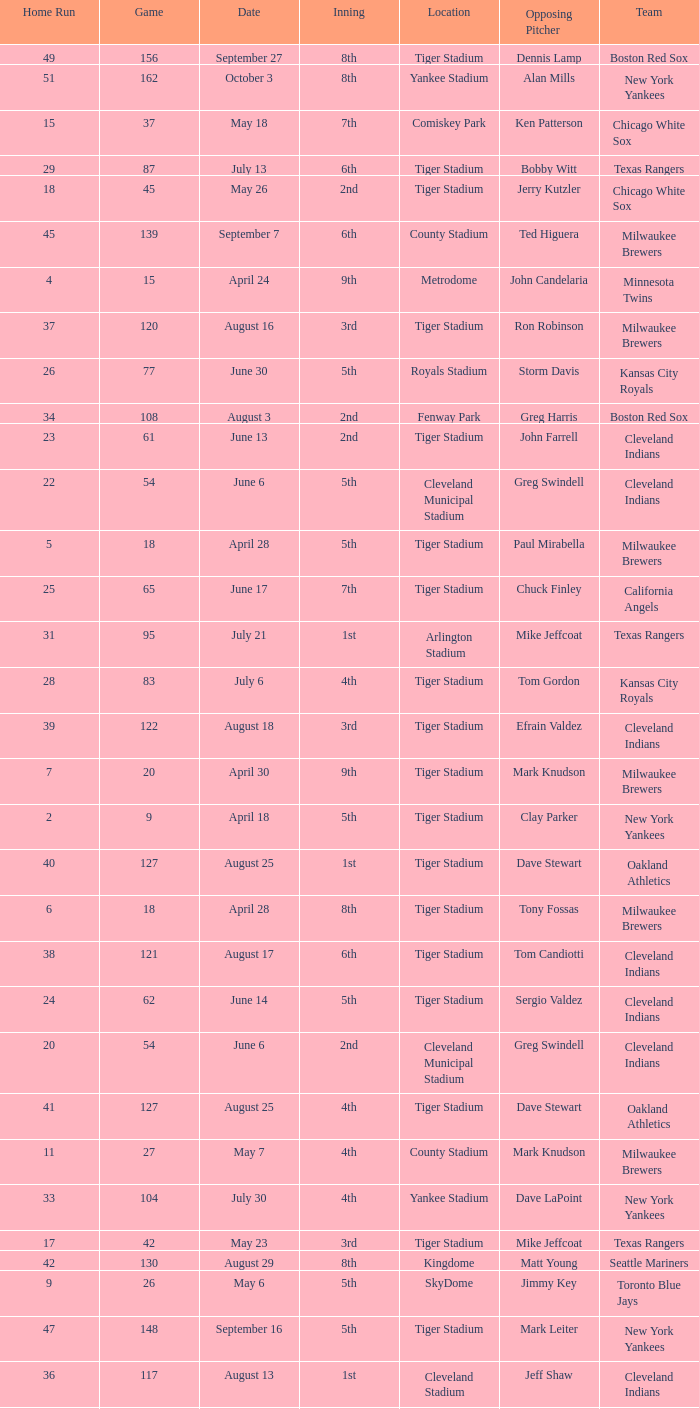On June 17 in Tiger stadium, what was the average home run? 25.0. 